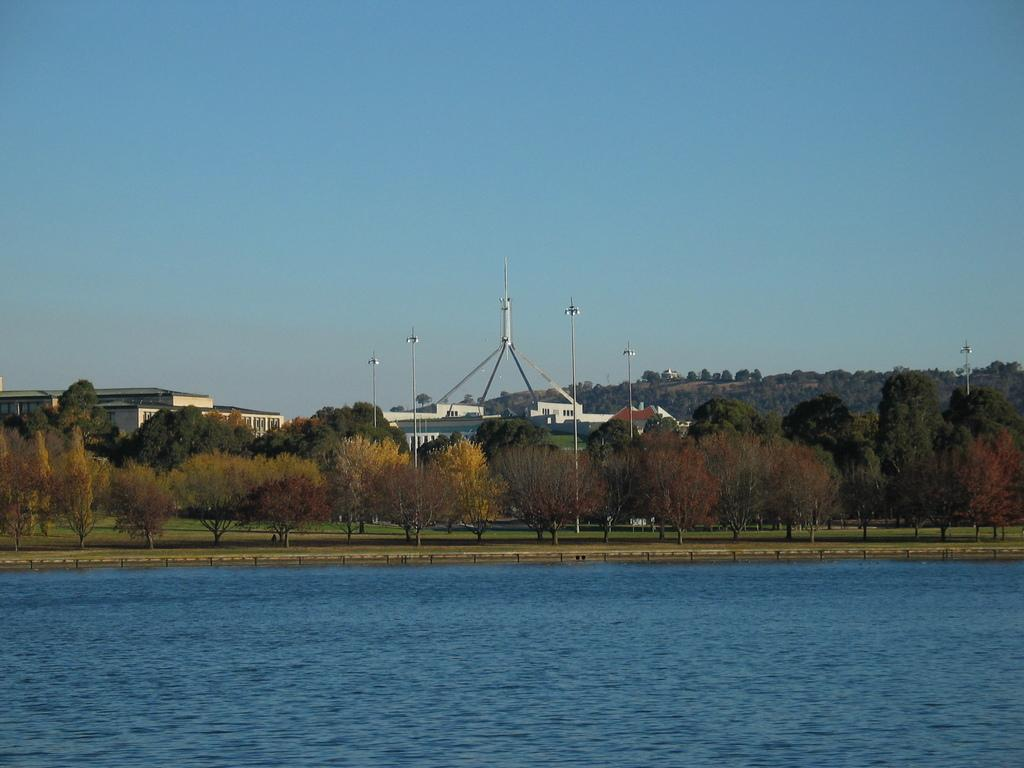What type of natural elements can be seen in the image? There are trees in the image. What type of man-made structures are visible in the image? There are buildings in the image. What type of vertical structures can be seen in the image? There are poles in the image. What other objects can be seen in the image besides trees, buildings, and poles? There are other objects in the image. What part of the natural environment is visible in the image? The sky is visible at the top of the image. What type of terrain or body of water is present at the bottom of the image? Water is present at the bottom of the image. What type of learning can be observed taking place in the image? There is no learning activity depicted in the image. What type of van is parked near the water in the image? There is no van present in the image. 